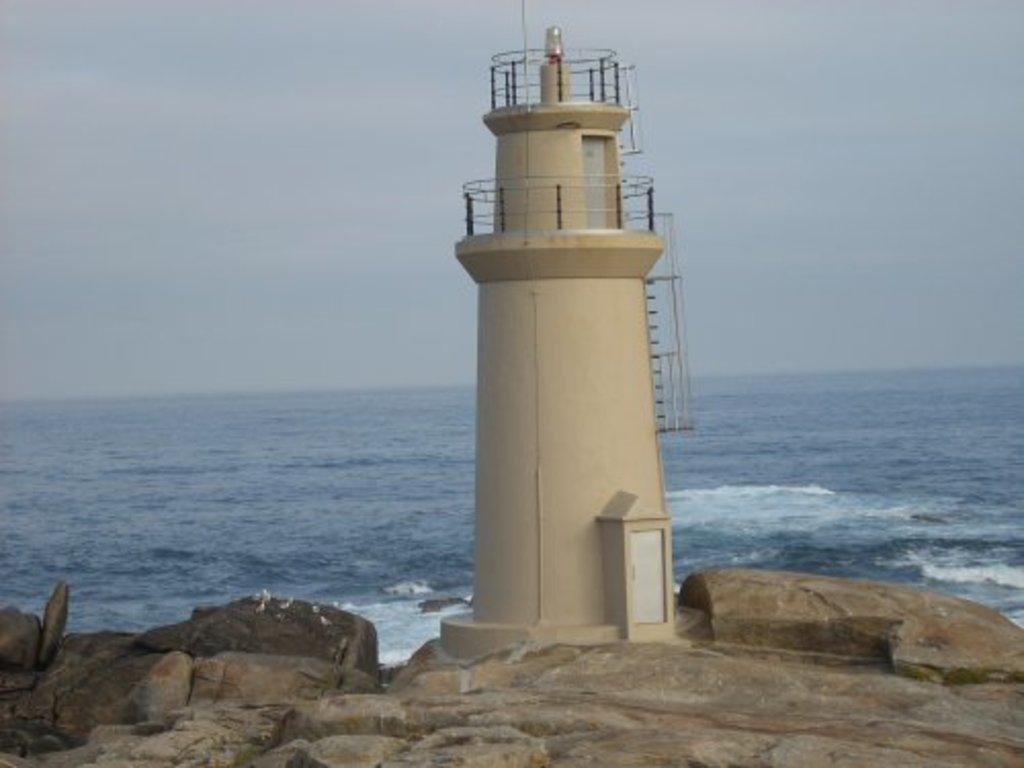What is the main structure in the center of the image? There is a tower in the center of the image. What can be seen at the bottom of the image? There are stones at the bottom of the image. What is located behind the tower in the image? There is an ocean behind the tower. What is visible in the background of the image? The sky is visible in the background of the image. What type of net is being used to catch fish in the image? There is no net or fish present in the image; it features a tower, stones, an ocean, and the sky. 